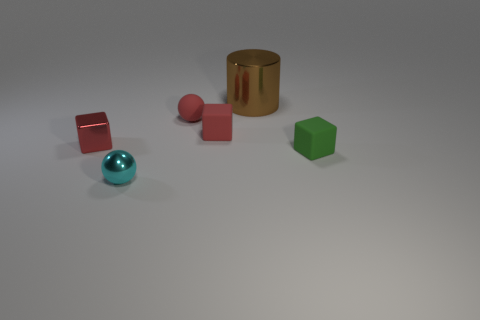Subtract all tiny red metallic cubes. How many cubes are left? 2 Add 3 cyan things. How many objects exist? 9 Subtract 1 spheres. How many spheres are left? 1 Subtract all green blocks. How many blocks are left? 2 Subtract all balls. How many objects are left? 4 Subtract all gray cylinders. Subtract all brown balls. How many cylinders are left? 1 Subtract all purple balls. How many yellow cubes are left? 0 Subtract all small red shiny objects. Subtract all red matte cubes. How many objects are left? 4 Add 1 cylinders. How many cylinders are left? 2 Add 2 small cyan rubber blocks. How many small cyan rubber blocks exist? 2 